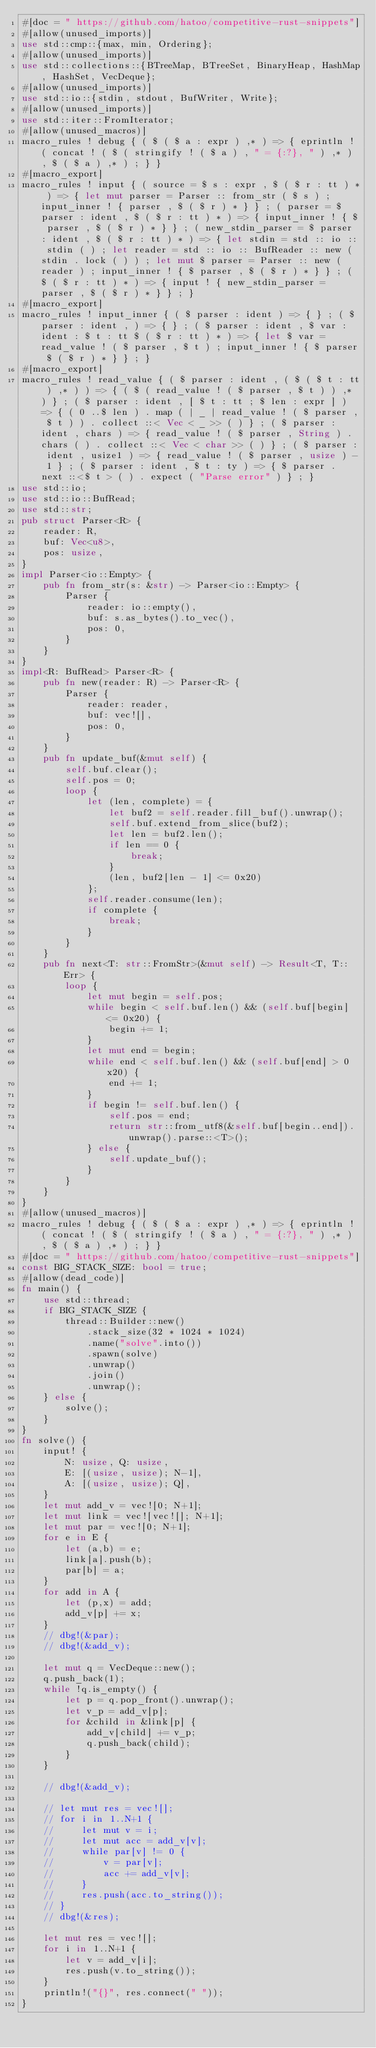Convert code to text. <code><loc_0><loc_0><loc_500><loc_500><_Rust_>#[doc = " https://github.com/hatoo/competitive-rust-snippets"]
#[allow(unused_imports)]
use std::cmp::{max, min, Ordering};
#[allow(unused_imports)]
use std::collections::{BTreeMap, BTreeSet, BinaryHeap, HashMap, HashSet, VecDeque};
#[allow(unused_imports)]
use std::io::{stdin, stdout, BufWriter, Write};
#[allow(unused_imports)]
use std::iter::FromIterator;
#[allow(unused_macros)]
macro_rules ! debug { ( $ ( $ a : expr ) ,* ) => { eprintln ! ( concat ! ( $ ( stringify ! ( $ a ) , " = {:?}, " ) ,* ) , $ ( $ a ) ,* ) ; } }
#[macro_export]
macro_rules ! input { ( source = $ s : expr , $ ( $ r : tt ) * ) => { let mut parser = Parser :: from_str ( $ s ) ; input_inner ! { parser , $ ( $ r ) * } } ; ( parser = $ parser : ident , $ ( $ r : tt ) * ) => { input_inner ! { $ parser , $ ( $ r ) * } } ; ( new_stdin_parser = $ parser : ident , $ ( $ r : tt ) * ) => { let stdin = std :: io :: stdin ( ) ; let reader = std :: io :: BufReader :: new ( stdin . lock ( ) ) ; let mut $ parser = Parser :: new ( reader ) ; input_inner ! { $ parser , $ ( $ r ) * } } ; ( $ ( $ r : tt ) * ) => { input ! { new_stdin_parser = parser , $ ( $ r ) * } } ; }
#[macro_export]
macro_rules ! input_inner { ( $ parser : ident ) => { } ; ( $ parser : ident , ) => { } ; ( $ parser : ident , $ var : ident : $ t : tt $ ( $ r : tt ) * ) => { let $ var = read_value ! ( $ parser , $ t ) ; input_inner ! { $ parser $ ( $ r ) * } } ; }
#[macro_export]
macro_rules ! read_value { ( $ parser : ident , ( $ ( $ t : tt ) ,* ) ) => { ( $ ( read_value ! ( $ parser , $ t ) ) ,* ) } ; ( $ parser : ident , [ $ t : tt ; $ len : expr ] ) => { ( 0 ..$ len ) . map ( | _ | read_value ! ( $ parser , $ t ) ) . collect ::< Vec < _ >> ( ) } ; ( $ parser : ident , chars ) => { read_value ! ( $ parser , String ) . chars ( ) . collect ::< Vec < char >> ( ) } ; ( $ parser : ident , usize1 ) => { read_value ! ( $ parser , usize ) - 1 } ; ( $ parser : ident , $ t : ty ) => { $ parser . next ::<$ t > ( ) . expect ( "Parse error" ) } ; }
use std::io;
use std::io::BufRead;
use std::str;
pub struct Parser<R> {
    reader: R,
    buf: Vec<u8>,
    pos: usize,
}
impl Parser<io::Empty> {
    pub fn from_str(s: &str) -> Parser<io::Empty> {
        Parser {
            reader: io::empty(),
            buf: s.as_bytes().to_vec(),
            pos: 0,
        }
    }
}
impl<R: BufRead> Parser<R> {
    pub fn new(reader: R) -> Parser<R> {
        Parser {
            reader: reader,
            buf: vec![],
            pos: 0,
        }
    }
    pub fn update_buf(&mut self) {
        self.buf.clear();
        self.pos = 0;
        loop {
            let (len, complete) = {
                let buf2 = self.reader.fill_buf().unwrap();
                self.buf.extend_from_slice(buf2);
                let len = buf2.len();
                if len == 0 {
                    break;
                }
                (len, buf2[len - 1] <= 0x20)
            };
            self.reader.consume(len);
            if complete {
                break;
            }
        }
    }
    pub fn next<T: str::FromStr>(&mut self) -> Result<T, T::Err> {
        loop {
            let mut begin = self.pos;
            while begin < self.buf.len() && (self.buf[begin] <= 0x20) {
                begin += 1;
            }
            let mut end = begin;
            while end < self.buf.len() && (self.buf[end] > 0x20) {
                end += 1;
            }
            if begin != self.buf.len() {
                self.pos = end;
                return str::from_utf8(&self.buf[begin..end]).unwrap().parse::<T>();
            } else {
                self.update_buf();
            }
        }
    }
}
#[allow(unused_macros)]
macro_rules ! debug { ( $ ( $ a : expr ) ,* ) => { eprintln ! ( concat ! ( $ ( stringify ! ( $ a ) , " = {:?}, " ) ,* ) , $ ( $ a ) ,* ) ; } }
#[doc = " https://github.com/hatoo/competitive-rust-snippets"]
const BIG_STACK_SIZE: bool = true;
#[allow(dead_code)]
fn main() {
    use std::thread;
    if BIG_STACK_SIZE {
        thread::Builder::new()
            .stack_size(32 * 1024 * 1024)
            .name("solve".into())
            .spawn(solve)
            .unwrap()
            .join()
            .unwrap();
    } else {
        solve();
    }
}
fn solve() {
    input! {
        N: usize, Q: usize,
        E: [(usize, usize); N-1],
        A: [(usize, usize); Q],
    }
    let mut add_v = vec![0; N+1];
    let mut link = vec![vec![]; N+1];
    let mut par = vec![0; N+1];
    for e in E {
        let (a,b) = e;
        link[a].push(b);
        par[b] = a;
    }
    for add in A {
        let (p,x) = add;
        add_v[p] += x;
    }
    // dbg!(&par);
    // dbg!(&add_v);

    let mut q = VecDeque::new();
    q.push_back(1);
    while !q.is_empty() {
        let p = q.pop_front().unwrap();
        let v_p = add_v[p];
        for &child in &link[p] {
            add_v[child] += v_p;
            q.push_back(child);
        }
    }

    // dbg!(&add_v);

    // let mut res = vec![];
    // for i in 1..N+1 {
    //     let mut v = i;
    //     let mut acc = add_v[v];
    //     while par[v] != 0 {
    //         v = par[v];
    //         acc += add_v[v];
    //     }
    //     res.push(acc.to_string());
    // }
    // dbg!(&res);

    let mut res = vec![];
    for i in 1..N+1 {
        let v = add_v[i];
        res.push(v.to_string());
    }
    println!("{}", res.connect(" "));
}</code> 